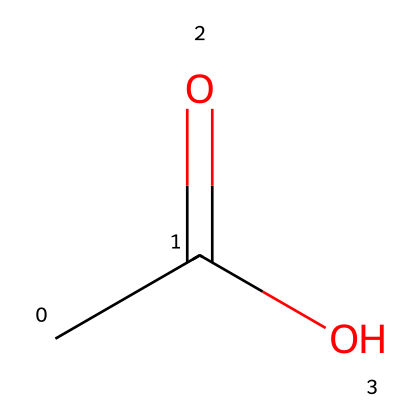What is the name of the chemical represented by this structure? The SMILES notation "CC(=O)O" describes acetic acid, which is a common organic acid. Therefore, the name is derived from the visible functional groups and structure within the chemical.
Answer: acetic acid How many carbon atoms are in the structure of this acid? In the SMILES "CC(=O)O", the first two C's represent two carbon atoms. Thus, counting these comes to a total of two carbon atoms in the acetic acid structure.
Answer: two What is the functional group present in this chemical? The "C(=O)O" part of the SMILES indicates a carboxylic acid functional group, which is characterized by a carbonyl (C=O) and hydroxyl (OH) group. This combination confirms that acetic acid fits the definition of a carboxylic acid.
Answer: carboxylic acid What type of bonding is indicated between the carbon and oxygen in the COOH group? In the SMILES notation "CC(=O)O", the "=" symbol between C and O in "C(=O)" represents a double bond, which is a specific type of bonding where two pairs of electrons are shared between these atoms.
Answer: double bond Why is this acid effective for cleaning computer peripherals? Acetic acid is an effective cleaning agent due to its ability to dissolve mineral deposits and cut through grease, which makes it particularly useful for cleaning various surfaces, including those found in computer peripherals.
Answer: dissolves mineral deposits What is the total number of hydrogen atoms in acetic acid? In the structure "CC(=O)O", each "C" contributes three hydrogens (in the case of one carbon) and one hydrogen from the hydroxyl group. Adding these gives a total of four hydrogen atoms for the acetic acid formula, C2H4O2.
Answer: four 